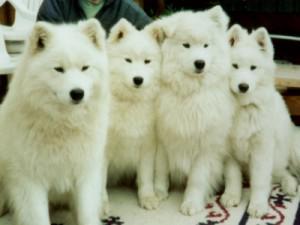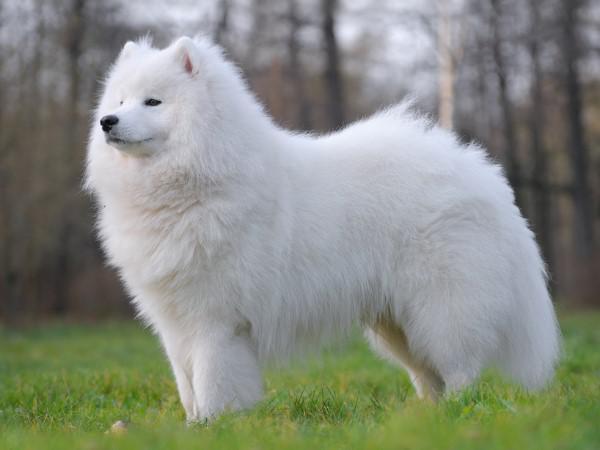The first image is the image on the left, the second image is the image on the right. For the images displayed, is the sentence "One of the images shows exactly two dogs." factually correct? Answer yes or no. No. 